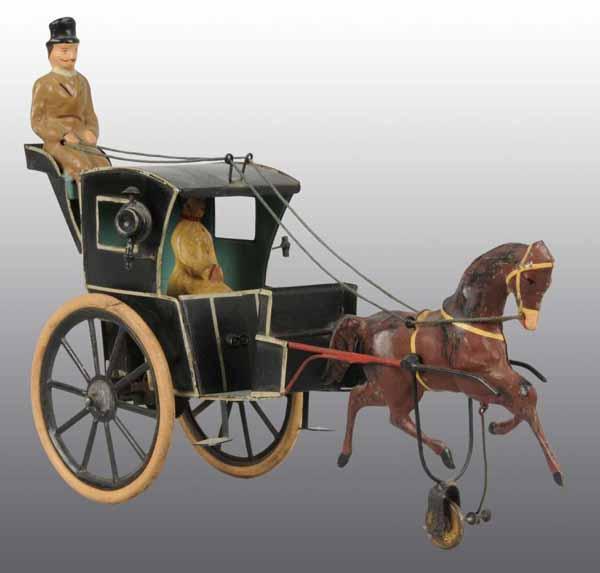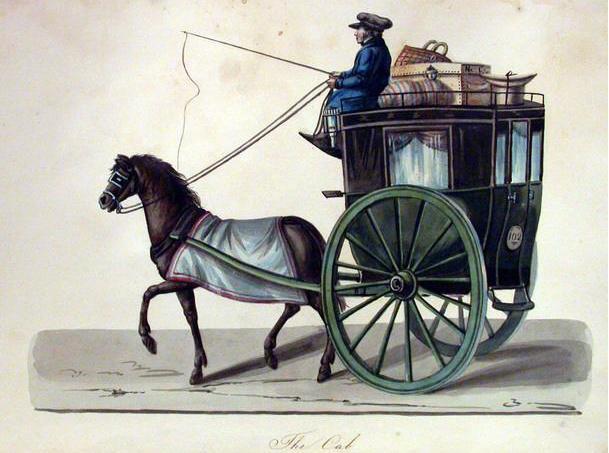The first image is the image on the left, the second image is the image on the right. For the images displayed, is the sentence "The left and right image contains a total of two horses facing the opposite directions." factually correct? Answer yes or no. Yes. The first image is the image on the left, the second image is the image on the right. Analyze the images presented: Is the assertion "One carriage driver is holding a whip." valid? Answer yes or no. Yes. 